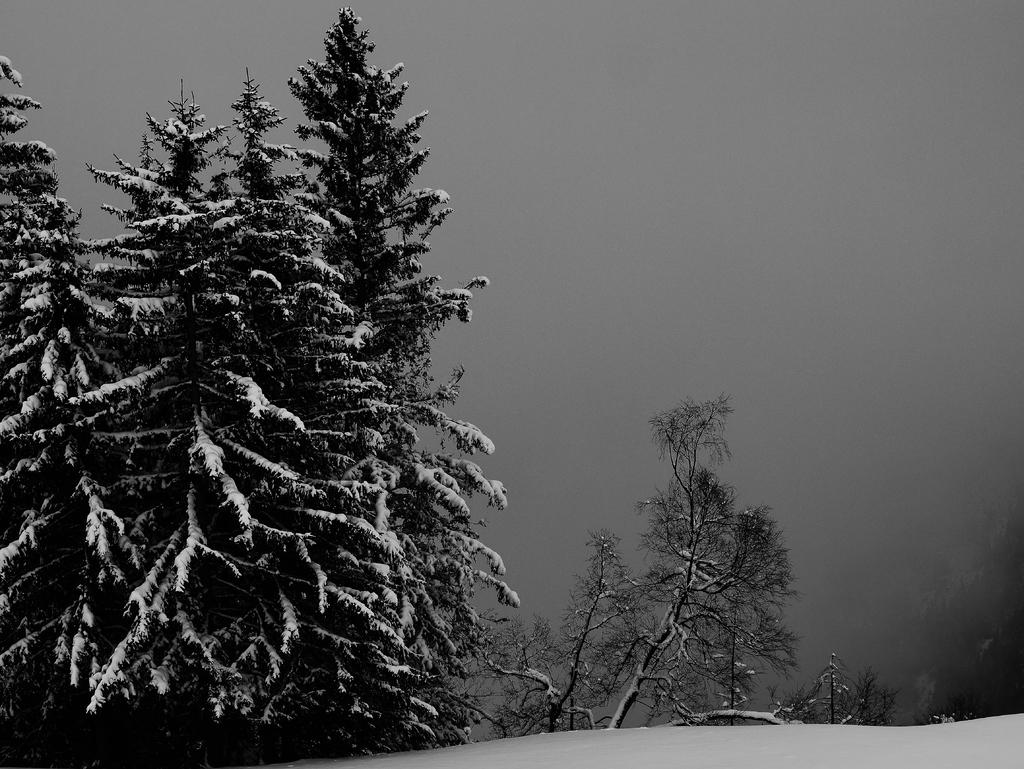What is the color scheme of the image? The image is black and white. What can be observed on the ground in the image? There is snow on the ground. What else is covered in snow in the image? The trees also have snow on them. What is visible in the background of the image? There is fog in the background. How does the sneeze affect the digestion of the person in the image? There is no person present in the image, and therefore no sneeze or digestion to consider. 